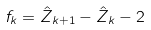<formula> <loc_0><loc_0><loc_500><loc_500>f _ { k } = \hat { Z } _ { k + 1 } - \hat { Z } _ { k } - 2</formula> 